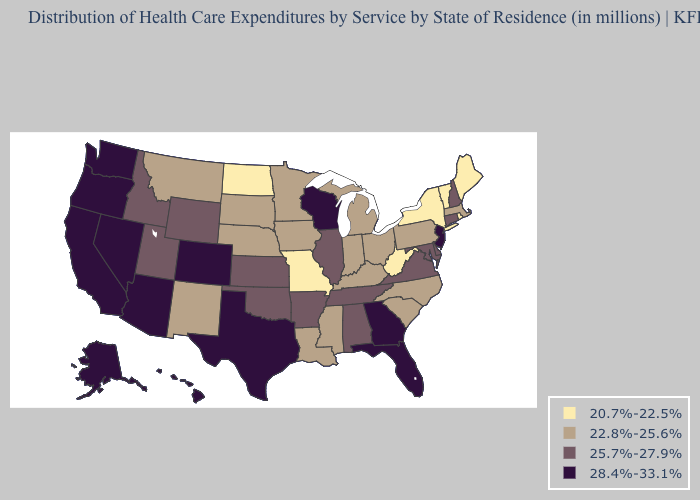Does Kansas have a lower value than Rhode Island?
Concise answer only. No. What is the value of Maine?
Quick response, please. 20.7%-22.5%. Name the states that have a value in the range 25.7%-27.9%?
Keep it brief. Alabama, Arkansas, Connecticut, Delaware, Idaho, Illinois, Kansas, Maryland, New Hampshire, Oklahoma, Tennessee, Utah, Virginia, Wyoming. Name the states that have a value in the range 20.7%-22.5%?
Quick response, please. Maine, Missouri, New York, North Dakota, Rhode Island, Vermont, West Virginia. Does New York have the lowest value in the USA?
Short answer required. Yes. Does Indiana have the highest value in the USA?
Short answer required. No. What is the value of Alabama?
Give a very brief answer. 25.7%-27.9%. Name the states that have a value in the range 22.8%-25.6%?
Short answer required. Indiana, Iowa, Kentucky, Louisiana, Massachusetts, Michigan, Minnesota, Mississippi, Montana, Nebraska, New Mexico, North Carolina, Ohio, Pennsylvania, South Carolina, South Dakota. Does Montana have the lowest value in the West?
Short answer required. Yes. Does Alabama have a higher value than Michigan?
Be succinct. Yes. Among the states that border New Hampshire , does Massachusetts have the lowest value?
Answer briefly. No. Name the states that have a value in the range 20.7%-22.5%?
Give a very brief answer. Maine, Missouri, New York, North Dakota, Rhode Island, Vermont, West Virginia. What is the value of Connecticut?
Be succinct. 25.7%-27.9%. What is the lowest value in the USA?
Give a very brief answer. 20.7%-22.5%. Name the states that have a value in the range 20.7%-22.5%?
Write a very short answer. Maine, Missouri, New York, North Dakota, Rhode Island, Vermont, West Virginia. 